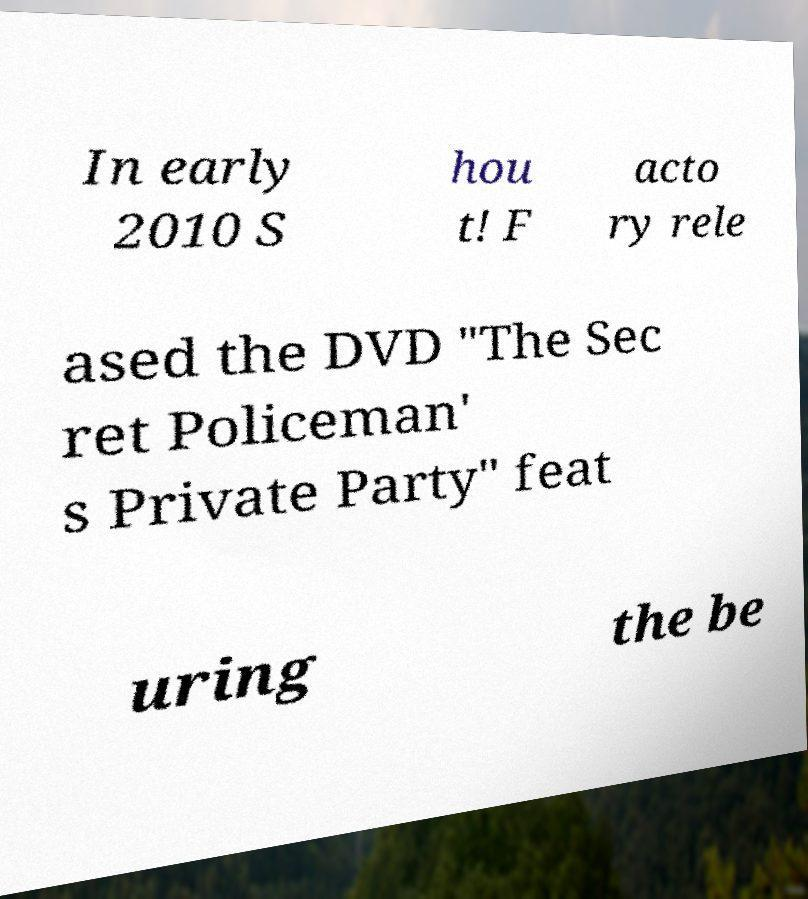For documentation purposes, I need the text within this image transcribed. Could you provide that? In early 2010 S hou t! F acto ry rele ased the DVD "The Sec ret Policeman' s Private Party" feat uring the be 